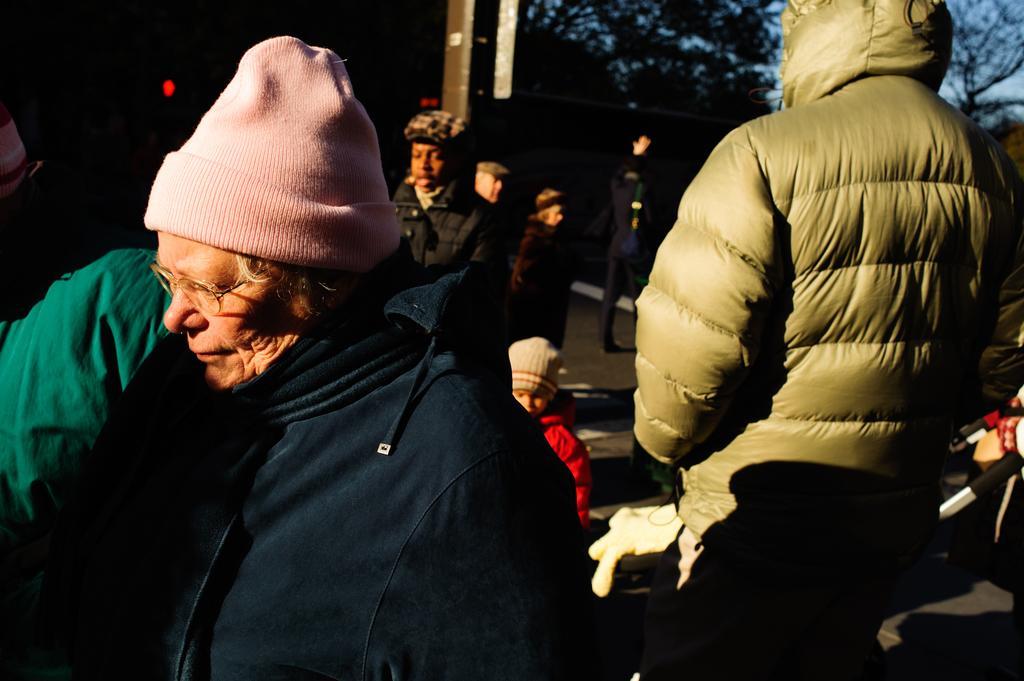Describe this image in one or two sentences. In the image we can see there are people standing on the ground and they are wearing jackets and head caps. Behind there are trees and background of the image is blurred. 